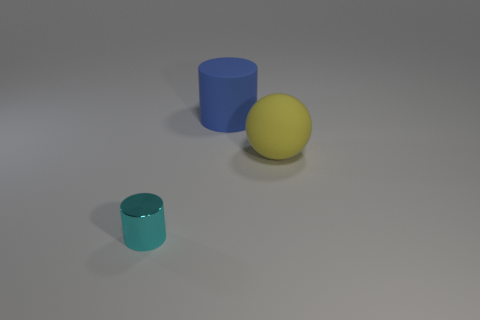Can you describe the shapes and colors present in the image? Certainly, the image depicts three objects. There's a yellow matte sphere, a blue cylinder, and a smaller teal cylinder, all placed against a neutral grey background. 